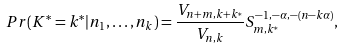<formula> <loc_0><loc_0><loc_500><loc_500>P r ( K ^ { * } = k ^ { * } | n _ { 1 } , \dots , n _ { k } ) = \frac { V _ { n + m , k + k ^ { * } } } { V _ { n , k } } S _ { m , k ^ { * } } ^ { - 1 , - \alpha , - ( n - k \alpha ) } ,</formula> 